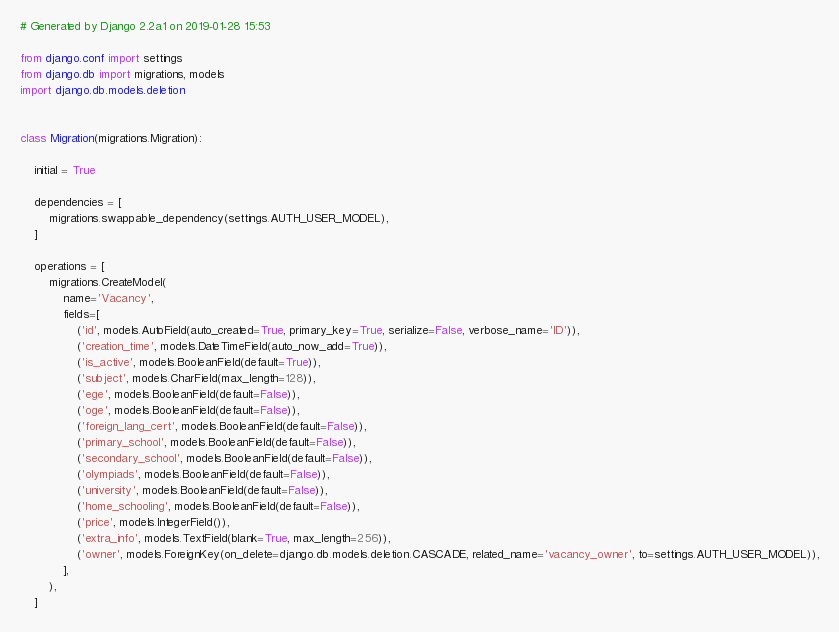<code> <loc_0><loc_0><loc_500><loc_500><_Python_># Generated by Django 2.2a1 on 2019-01-28 15:53

from django.conf import settings
from django.db import migrations, models
import django.db.models.deletion


class Migration(migrations.Migration):

    initial = True

    dependencies = [
        migrations.swappable_dependency(settings.AUTH_USER_MODEL),
    ]

    operations = [
        migrations.CreateModel(
            name='Vacancy',
            fields=[
                ('id', models.AutoField(auto_created=True, primary_key=True, serialize=False, verbose_name='ID')),
                ('creation_time', models.DateTimeField(auto_now_add=True)),
                ('is_active', models.BooleanField(default=True)),
                ('subject', models.CharField(max_length=128)),
                ('ege', models.BooleanField(default=False)),
                ('oge', models.BooleanField(default=False)),
                ('foreign_lang_cert', models.BooleanField(default=False)),
                ('primary_school', models.BooleanField(default=False)),
                ('secondary_school', models.BooleanField(default=False)),
                ('olympiads', models.BooleanField(default=False)),
                ('university', models.BooleanField(default=False)),
                ('home_schooling', models.BooleanField(default=False)),
                ('price', models.IntegerField()),
                ('extra_info', models.TextField(blank=True, max_length=256)),
                ('owner', models.ForeignKey(on_delete=django.db.models.deletion.CASCADE, related_name='vacancy_owner', to=settings.AUTH_USER_MODEL)),
            ],
        ),
    ]
</code> 